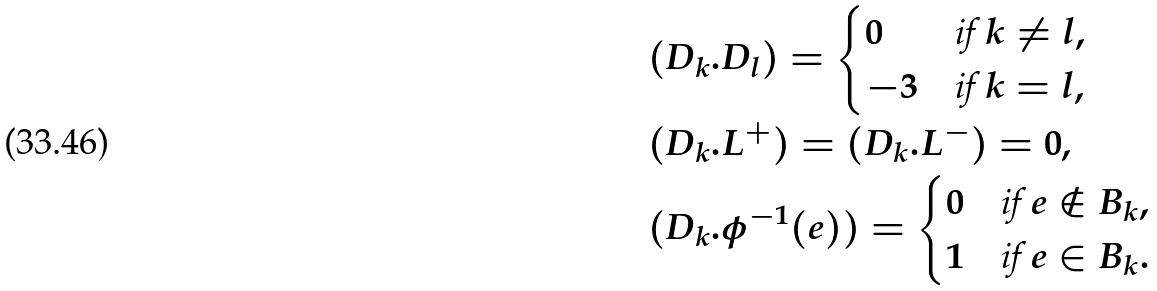<formula> <loc_0><loc_0><loc_500><loc_500>& ( D _ { k } . D _ { l } ) = \begin{cases} 0 & \text {if $k\neq{l}$} , \\ - 3 & \text {if $k=l$} , \end{cases} \\ & ( D _ { k } . L ^ { + } ) = ( D _ { k } . L ^ { - } ) = 0 , \\ & ( D _ { k } . \phi ^ { - 1 } ( e ) ) = \begin{cases} 0 & \text {if $e\notin{B_{k}}$} , \\ 1 & \text {if $e\in{B_{k}}$} . \end{cases}</formula> 